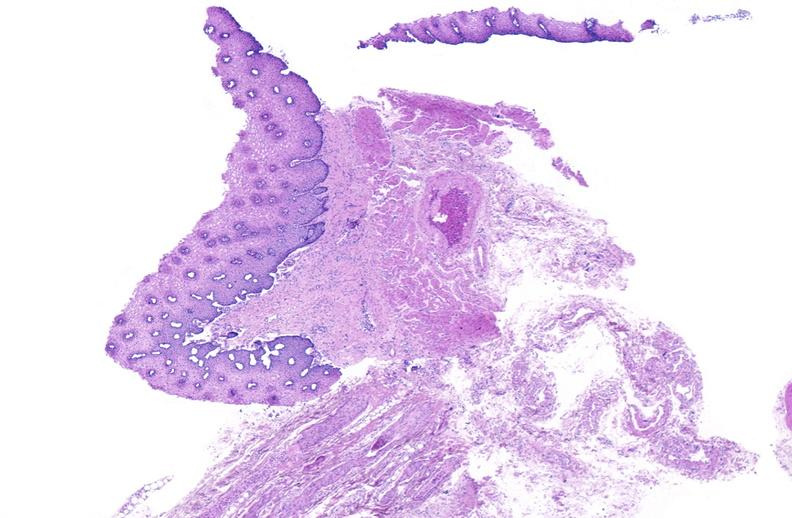what is present?
Answer the question using a single word or phrase. Gastrointestinal 